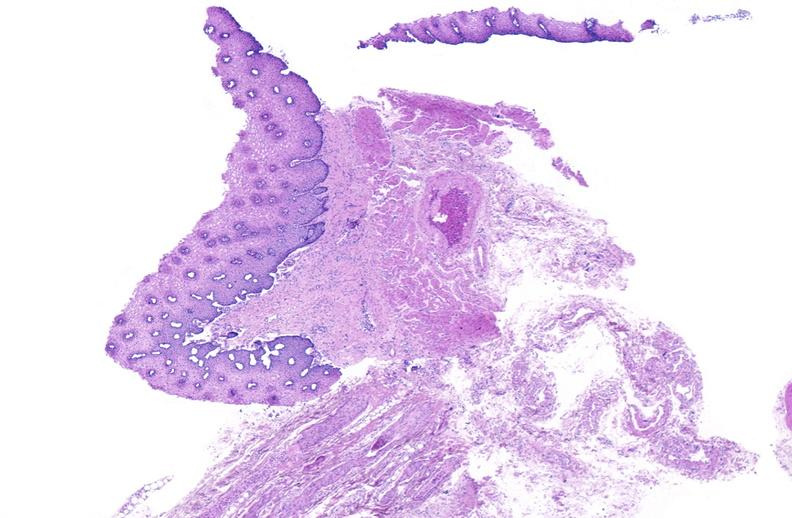what is present?
Answer the question using a single word or phrase. Gastrointestinal 